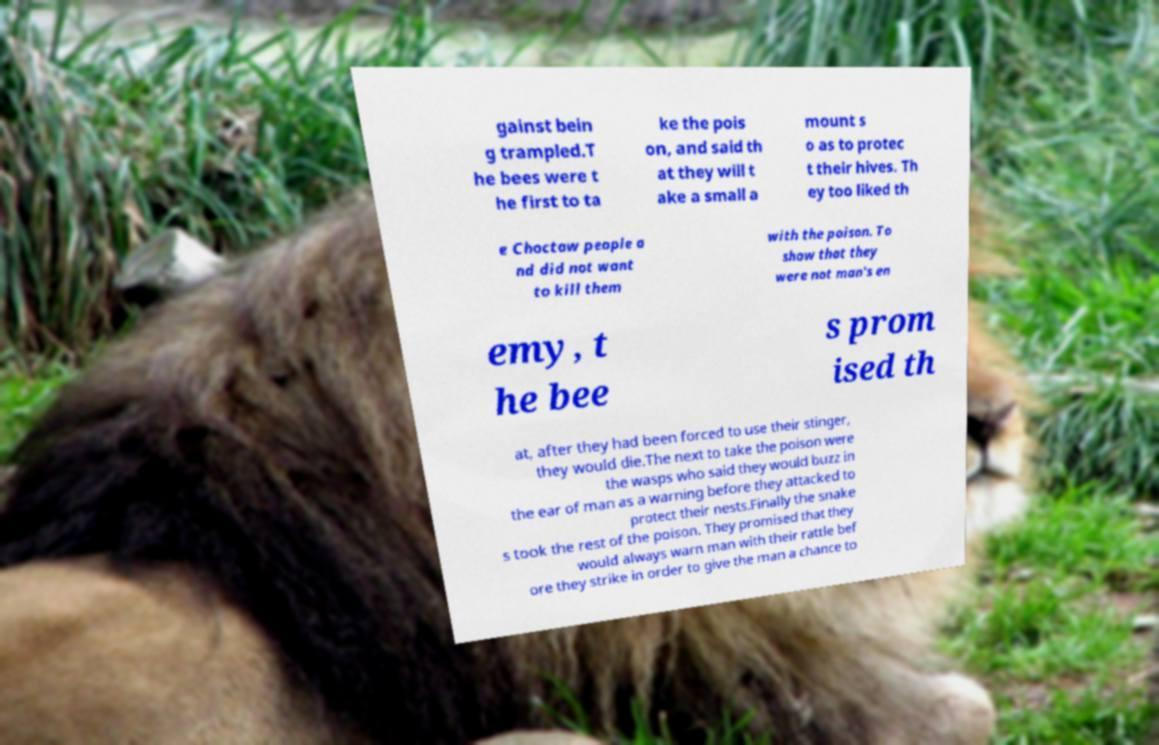There's text embedded in this image that I need extracted. Can you transcribe it verbatim? gainst bein g trampled.T he bees were t he first to ta ke the pois on, and said th at they will t ake a small a mount s o as to protec t their hives. Th ey too liked th e Choctaw people a nd did not want to kill them with the poison. To show that they were not man's en emy, t he bee s prom ised th at, after they had been forced to use their stinger, they would die.The next to take the poison were the wasps who said they would buzz in the ear of man as a warning before they attacked to protect their nests.Finally the snake s took the rest of the poison. They promised that they would always warn man with their rattle bef ore they strike in order to give the man a chance to 